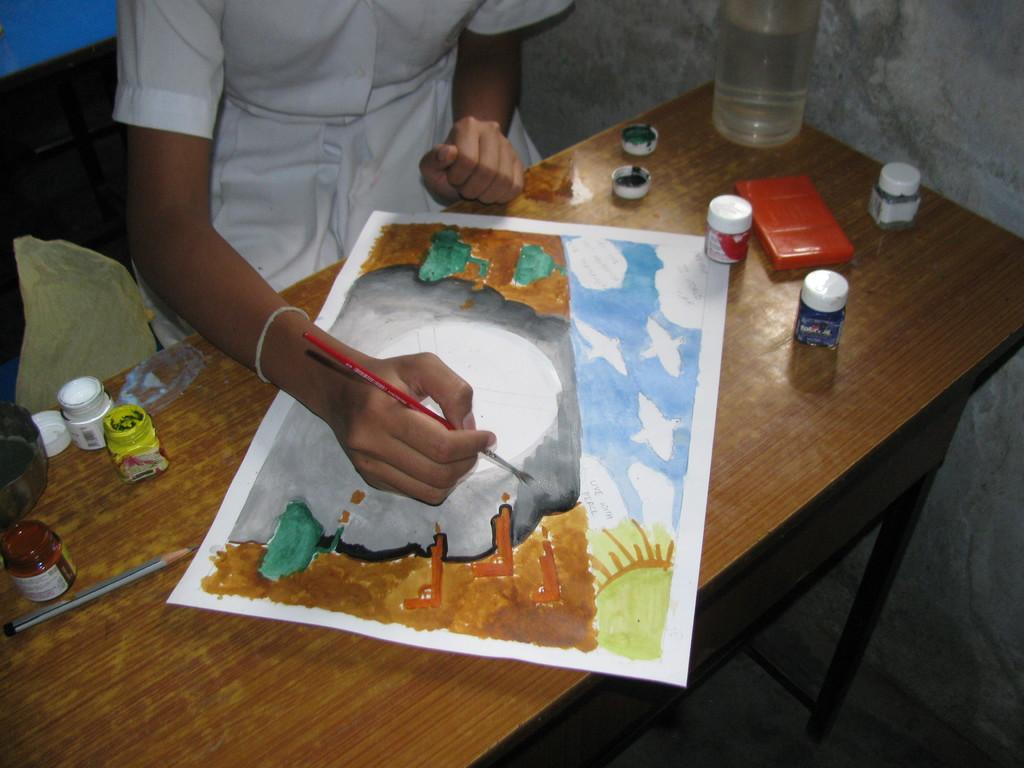Who is the main subject in the image? There is a girl in the image. Where is the girl located in the image? The girl is at the top side of the image. What is the girl doing in the image? The girl is painting on the bench. What items are related to the girl's activity in the image? There are paint bottles on the bench. Is the girl standing in quicksand while painting in the image? No, there is no quicksand present in the image. The girl is sitting on a bench while painting. 